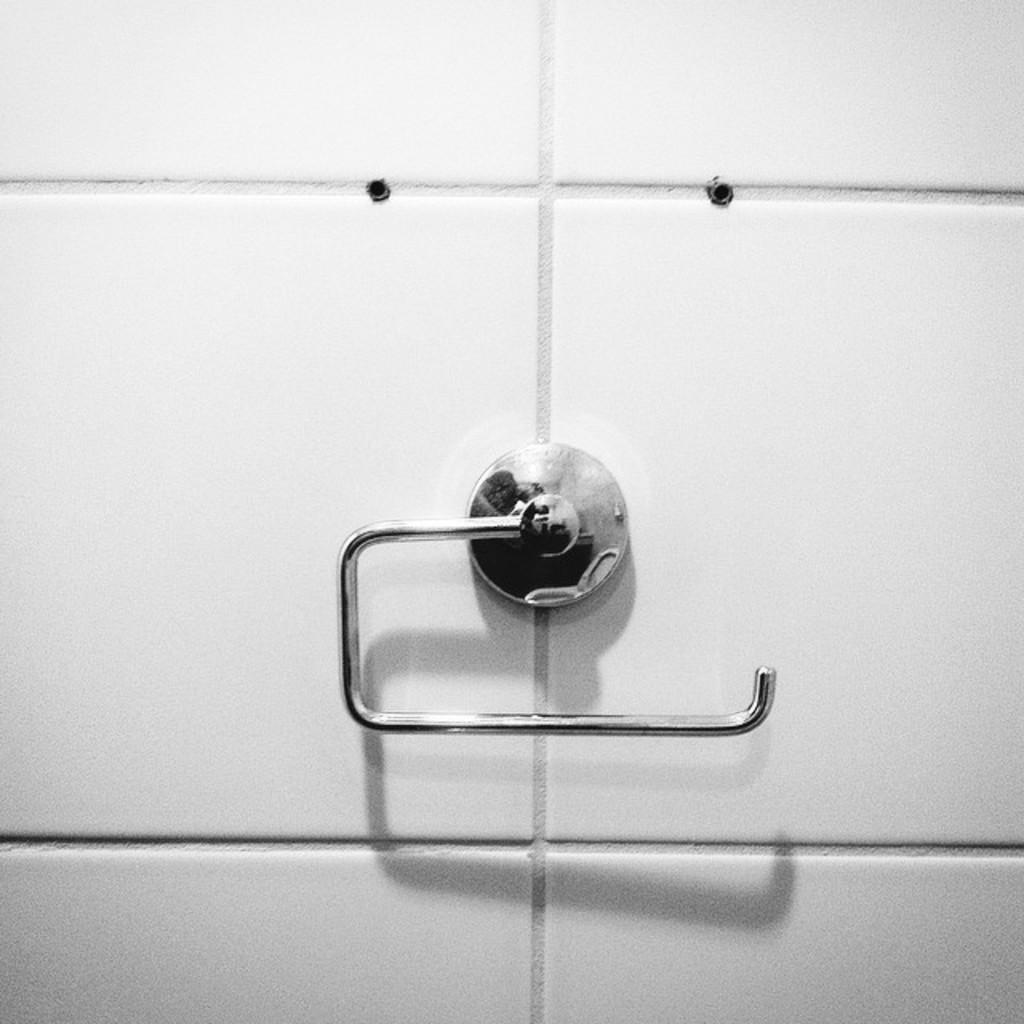What type of towel stand is in the image? There is a stainless steel towel stand in the image. How is the towel stand positioned in the image? The towel stand is mounted on the wall. How many cups are placed on the towel stand in the image? There are no cups present on the towel stand in the image. What type of planes can be seen flying in the background of the image? There are no planes visible in the image; it only features a stainless steel towel stand mounted on the wall. 